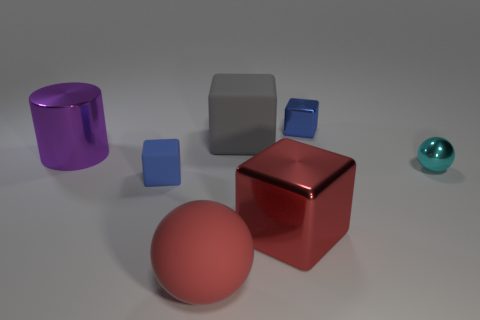Can you speculate on the material of the turquoise sphere? While it's not possible to determine the exact material from the image alone, the turquoise sphere has a high-gloss finish that suggests it could be made of a polished gemstone or glass. 